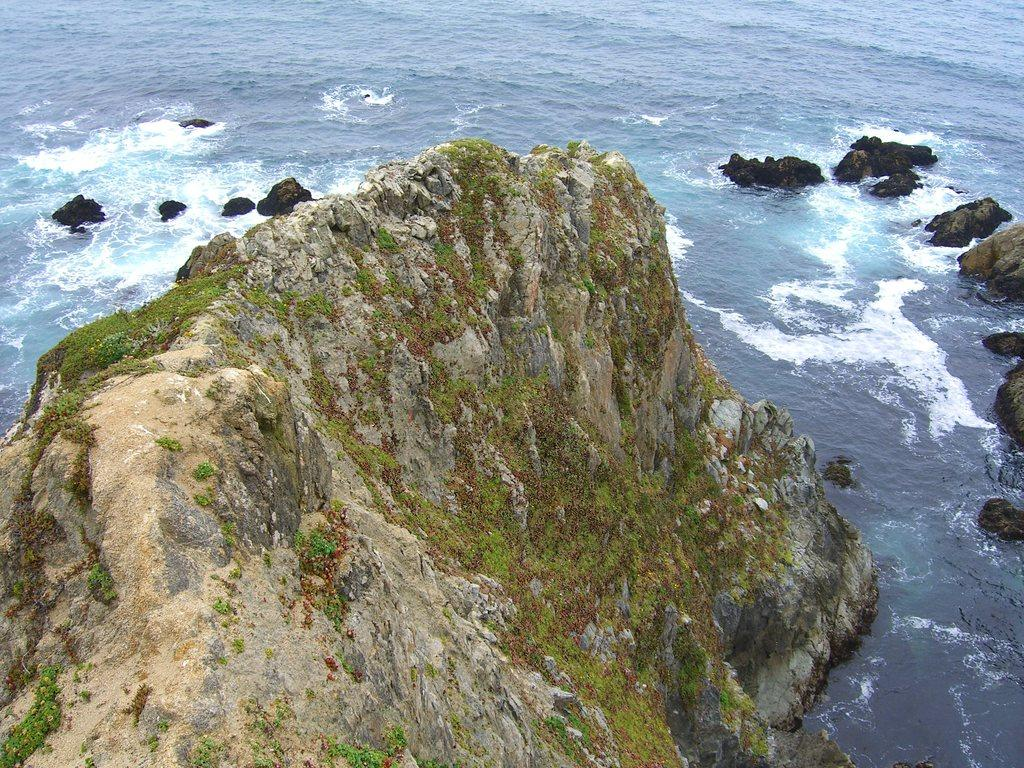What type of natural elements can be seen in the image? There are rocks in the image. What can be seen in the background of the image? There is water visible in the background of the image. What letters can be seen on the rocks in the image? There are no letters visible on the rocks in the image. 